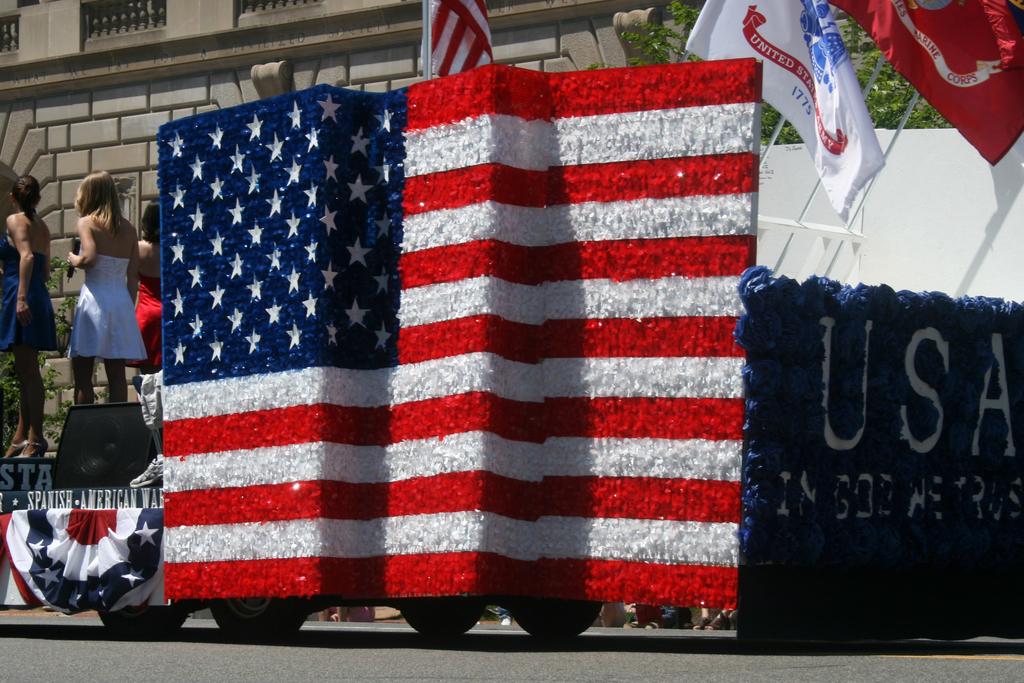What is spelled out in white with a blue background?
Provide a succinct answer. Usa. What war is written on the float?
Offer a terse response. Spanish-american war. 